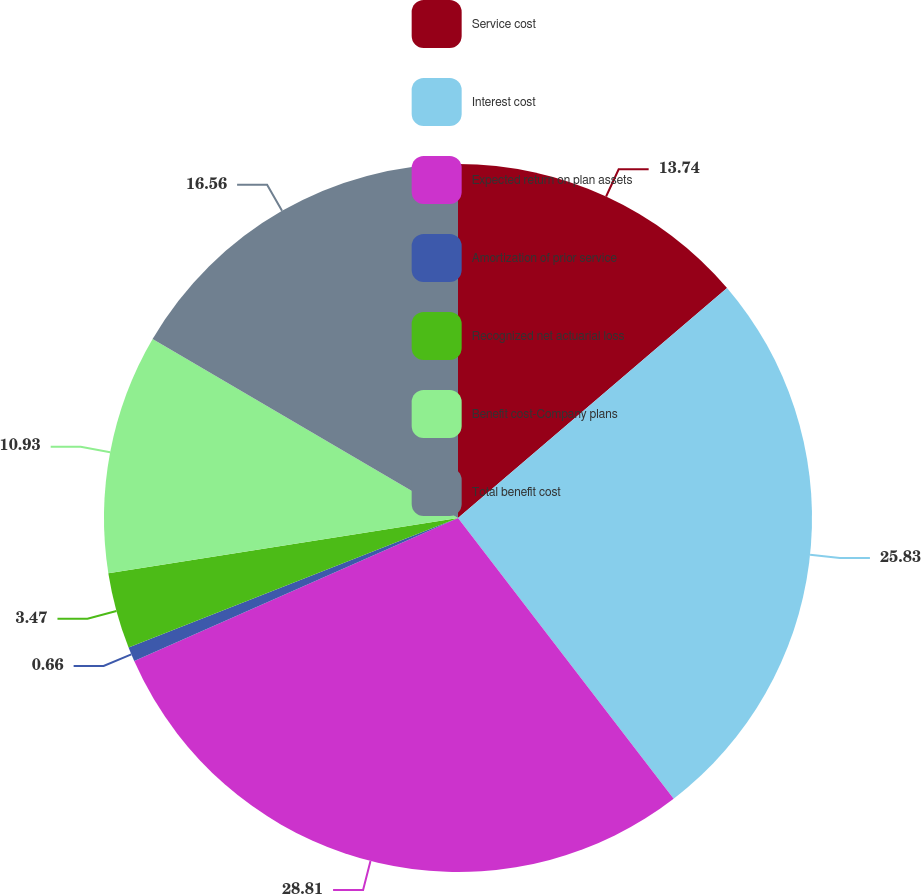Convert chart to OTSL. <chart><loc_0><loc_0><loc_500><loc_500><pie_chart><fcel>Service cost<fcel>Interest cost<fcel>Expected return on plan assets<fcel>Amortization of prior service<fcel>Recognized net actuarial loss<fcel>Benefit cost-Company plans<fcel>Total benefit cost<nl><fcel>13.74%<fcel>25.83%<fcel>28.8%<fcel>0.66%<fcel>3.47%<fcel>10.93%<fcel>16.56%<nl></chart> 